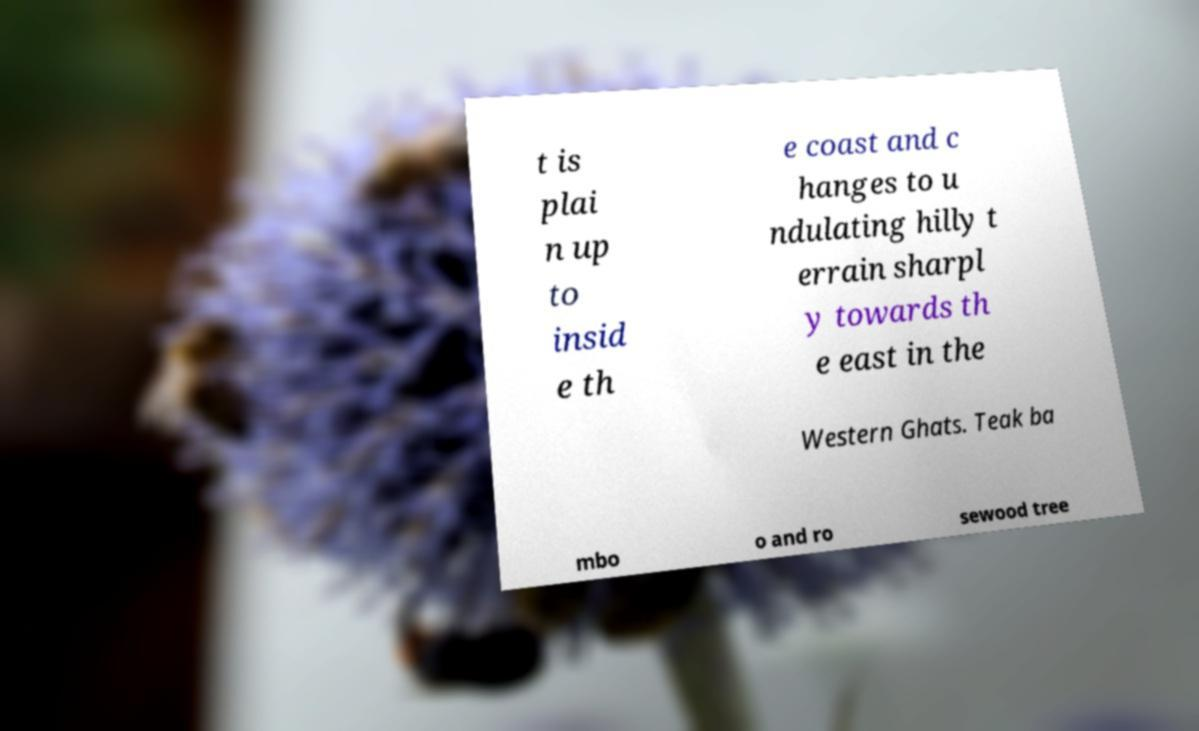Please identify and transcribe the text found in this image. t is plai n up to insid e th e coast and c hanges to u ndulating hilly t errain sharpl y towards th e east in the Western Ghats. Teak ba mbo o and ro sewood tree 